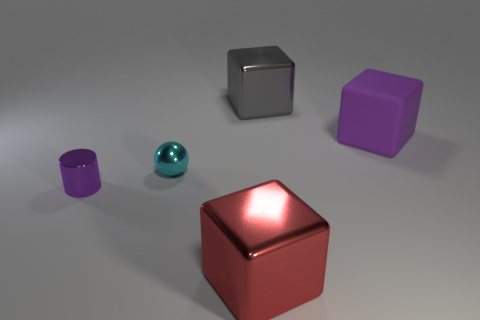Is there anything else that is the same size as the red block?
Offer a terse response. Yes. Are there any green matte objects of the same size as the shiny cylinder?
Your answer should be very brief. No. There is a object that is the same size as the sphere; what shape is it?
Give a very brief answer. Cylinder. Is there a large cyan shiny object that has the same shape as the big red metal thing?
Ensure brevity in your answer.  No. Is the small purple object made of the same material as the big block that is in front of the tiny cyan metal sphere?
Offer a terse response. Yes. Are there any large cubes of the same color as the matte thing?
Your response must be concise. No. What number of other objects are the same material as the tiny cyan sphere?
Provide a succinct answer. 3. Is the color of the metal cylinder the same as the large metallic object in front of the cyan metallic object?
Your response must be concise. No. Are there more large matte things that are to the left of the small ball than things?
Your answer should be very brief. No. What number of small purple things are on the right side of the metallic thing in front of the metallic object that is on the left side of the small shiny sphere?
Offer a very short reply. 0. 